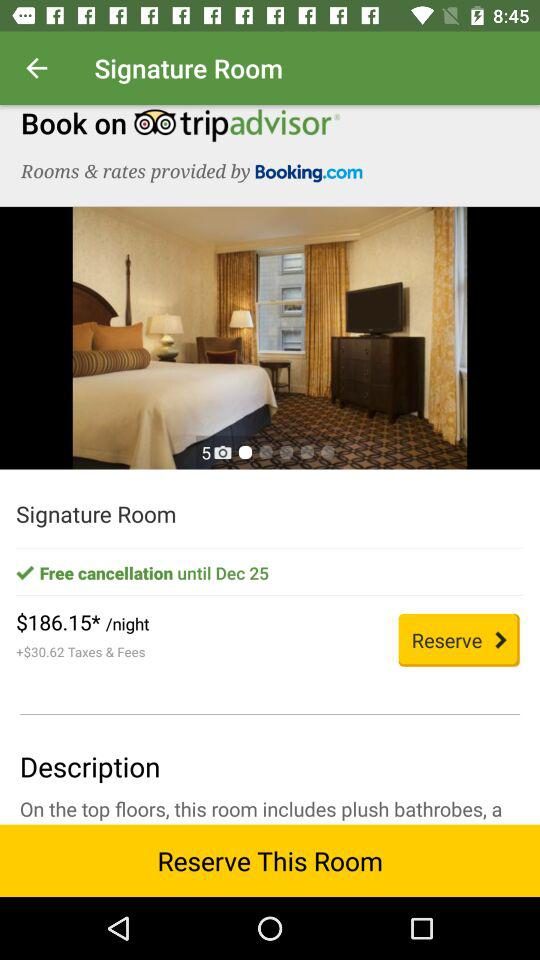How much more is the total cost than the cost of the room per night?
Answer the question using a single word or phrase. $30.62 